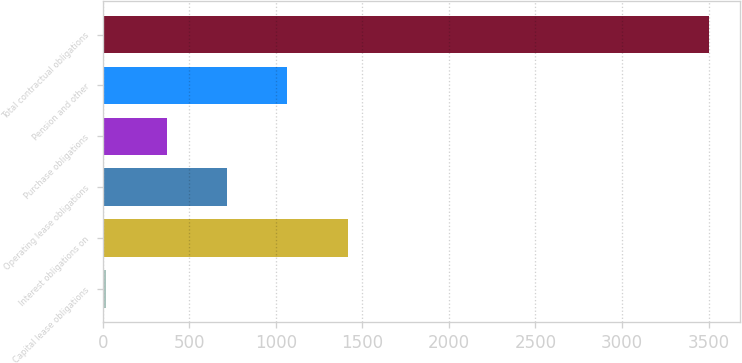<chart> <loc_0><loc_0><loc_500><loc_500><bar_chart><fcel>Capital lease obligations<fcel>Interest obligations on<fcel>Operating lease obligations<fcel>Purchase obligations<fcel>Pension and other<fcel>Total contractual obligations<nl><fcel>21.5<fcel>1414.58<fcel>718.04<fcel>369.77<fcel>1066.31<fcel>3504.2<nl></chart> 